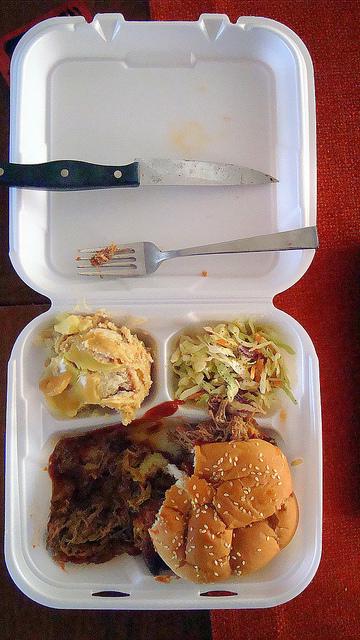Is this an adult's lunch?
Write a very short answer. Yes. What is the container made of?
Short answer required. Styrofoam. What is wrapped around the hot dog?
Give a very brief answer. Bun. What kind of bread is this?
Quick response, please. Bun. Is the fork clean with this lunch?
Be succinct. No. Is a spoon needed?
Short answer required. No. What utensils was the diner using?
Be succinct. Fork and knife. 